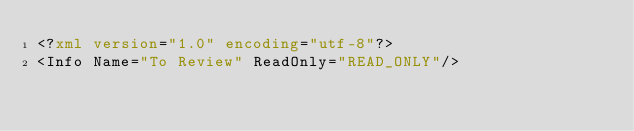Convert code to text. <code><loc_0><loc_0><loc_500><loc_500><_XML_><?xml version="1.0" encoding="utf-8"?>
<Info Name="To Review" ReadOnly="READ_ONLY"/></code> 